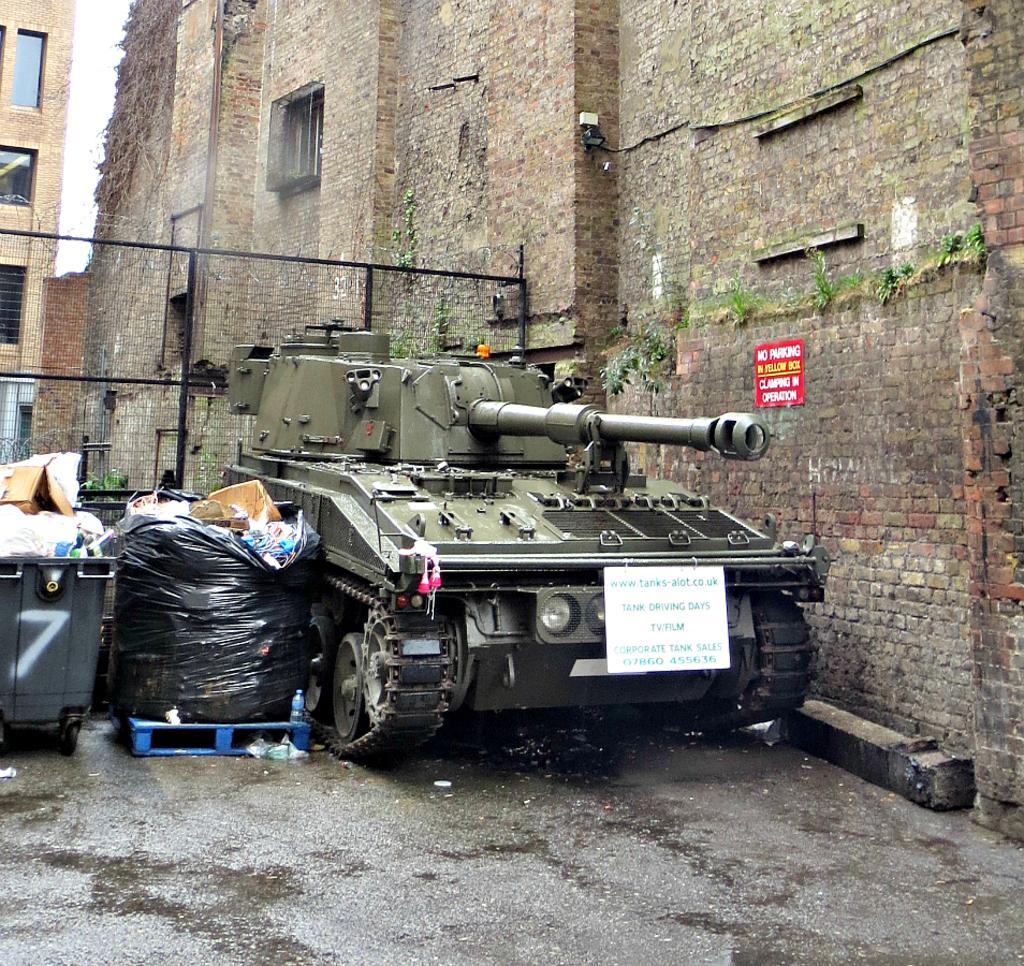Could you give a brief overview of what you see in this image? In this image, we can see a military tank and some dustbins. We can see the ground and the wall with some objects. We can see the fence and a building. We can also the sky. 